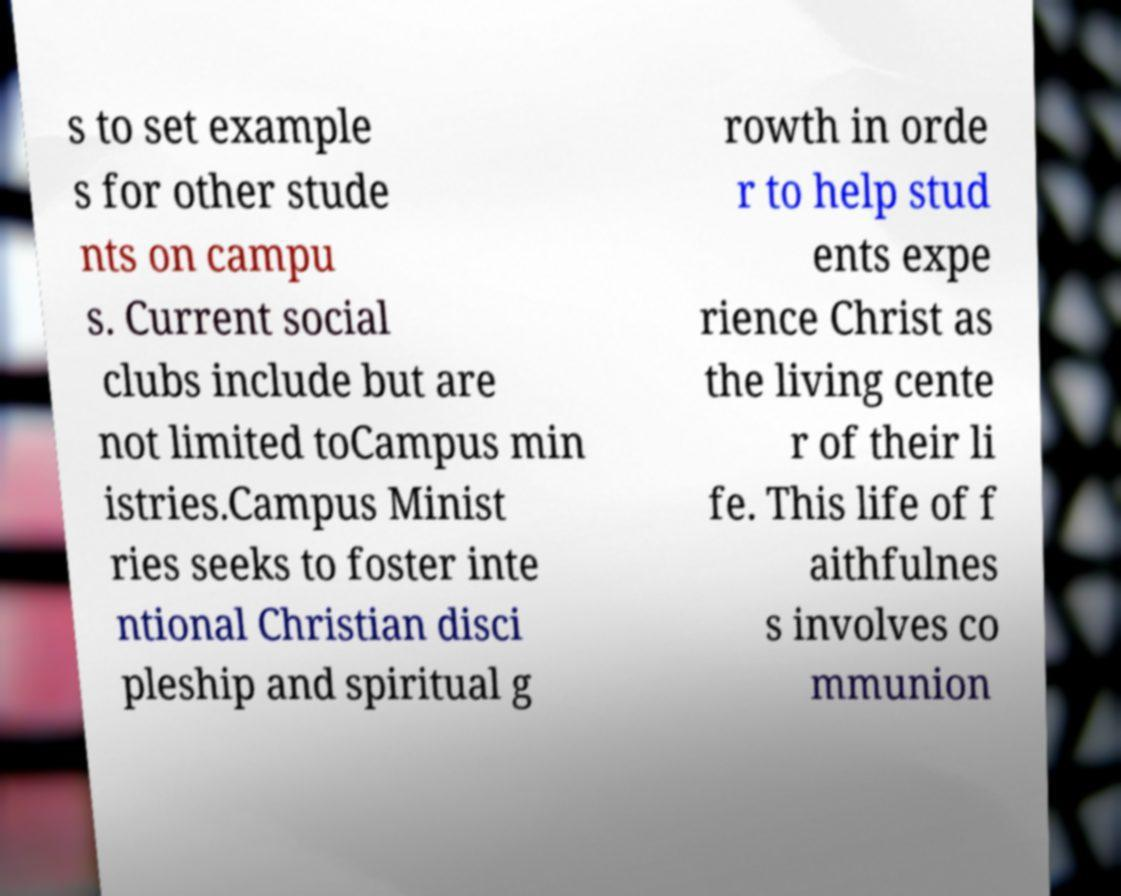There's text embedded in this image that I need extracted. Can you transcribe it verbatim? s to set example s for other stude nts on campu s. Current social clubs include but are not limited toCampus min istries.Campus Minist ries seeks to foster inte ntional Christian disci pleship and spiritual g rowth in orde r to help stud ents expe rience Christ as the living cente r of their li fe. This life of f aithfulnes s involves co mmunion 